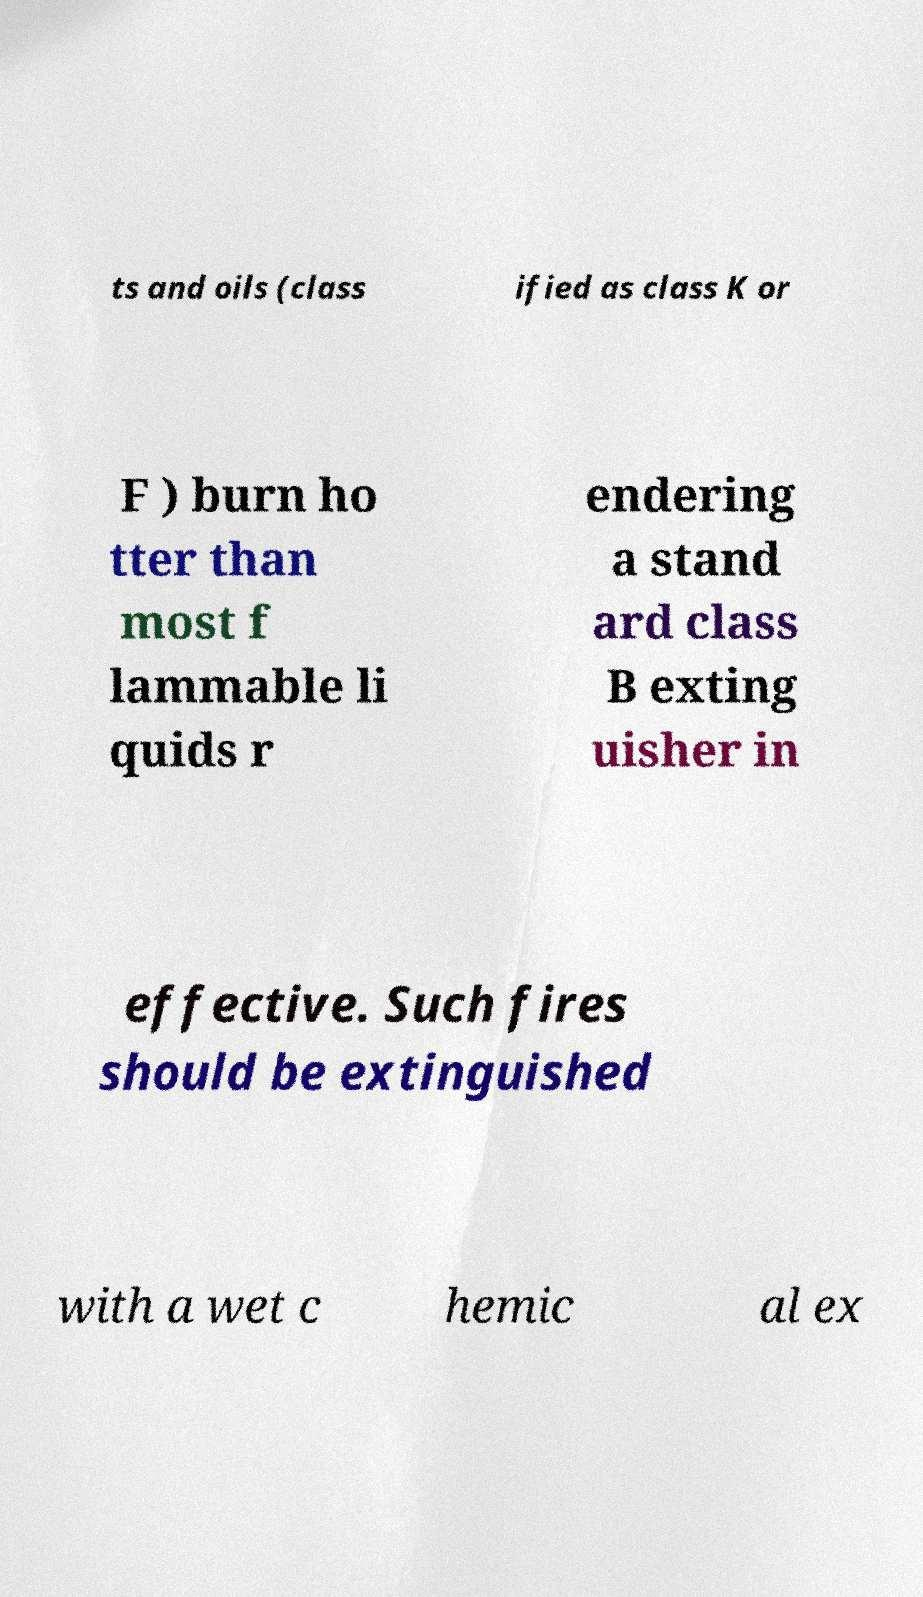There's text embedded in this image that I need extracted. Can you transcribe it verbatim? ts and oils (class ified as class K or F ) burn ho tter than most f lammable li quids r endering a stand ard class B exting uisher in effective. Such fires should be extinguished with a wet c hemic al ex 